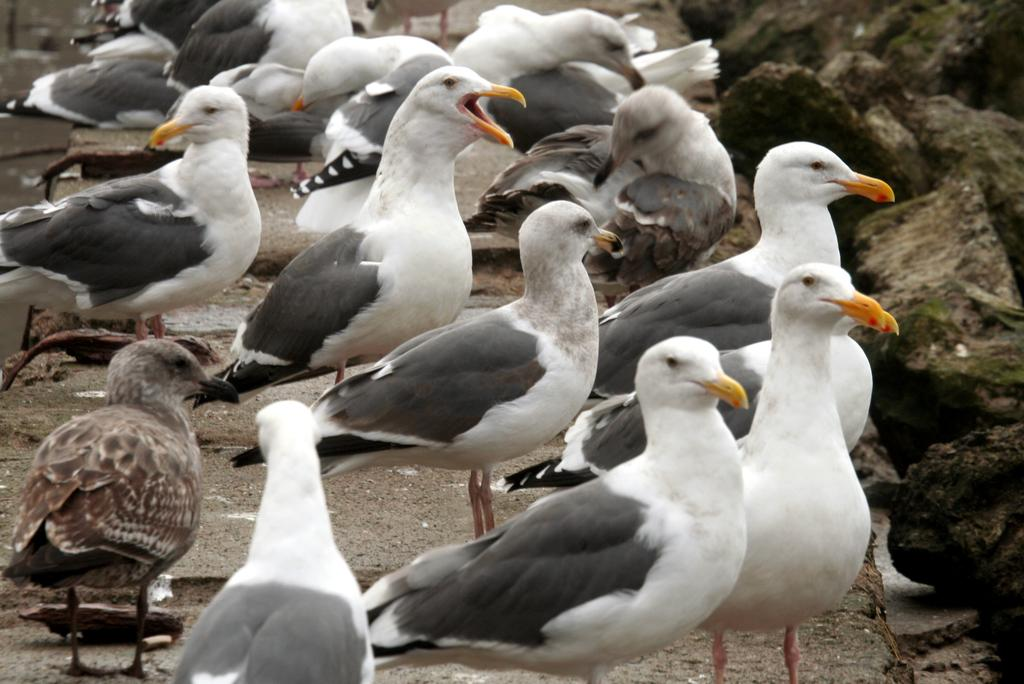What type of animals can be seen in the image? There are birds in the image. Can you describe the appearance of the birds? The birds are in different colors. What else is present in the image besides the birds? There are rocks in the image. What type of pizzas can be seen in the image}? There are no pizzas present in the image. 